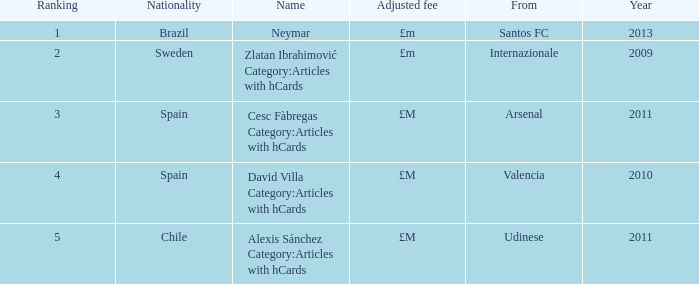I'm looking to parse the entire table for insights. Could you assist me with that? {'header': ['Ranking', 'Nationality', 'Name', 'Adjusted fee', 'From', 'Year'], 'rows': [['1', 'Brazil', 'Neymar', '£m', 'Santos FC', '2013'], ['2', 'Sweden', 'Zlatan Ibrahimović Category:Articles with hCards', '£m', 'Internazionale', '2009'], ['3', 'Spain', 'Cesc Fàbregas Category:Articles with hCards', '£M', 'Arsenal', '2011'], ['4', 'Spain', 'David Villa Category:Articles with hCards', '£M', 'Valencia', '2010'], ['5', 'Chile', 'Alexis Sánchez Category:Articles with hCards', '£M', 'Udinese', '2011']]} From which most recent year does a player come from valencia? 2010.0. 